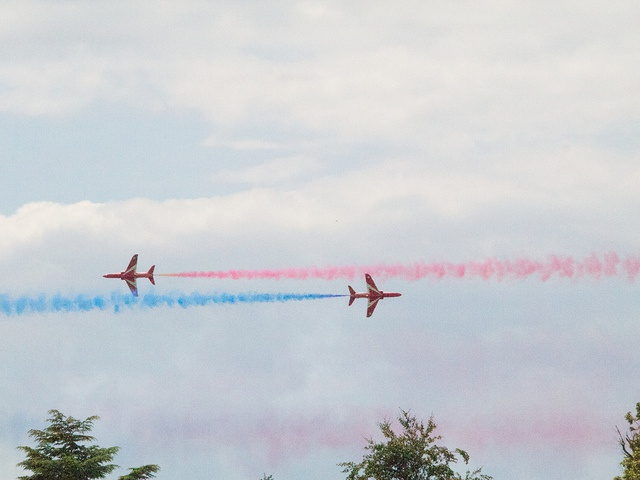Describe the objects in this image and their specific colors. I can see airplane in lightgray, brown, and darkgray tones and airplane in lightgray, brown, and darkgray tones in this image. 